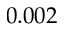<formula> <loc_0><loc_0><loc_500><loc_500>0 . 0 0 2</formula> 